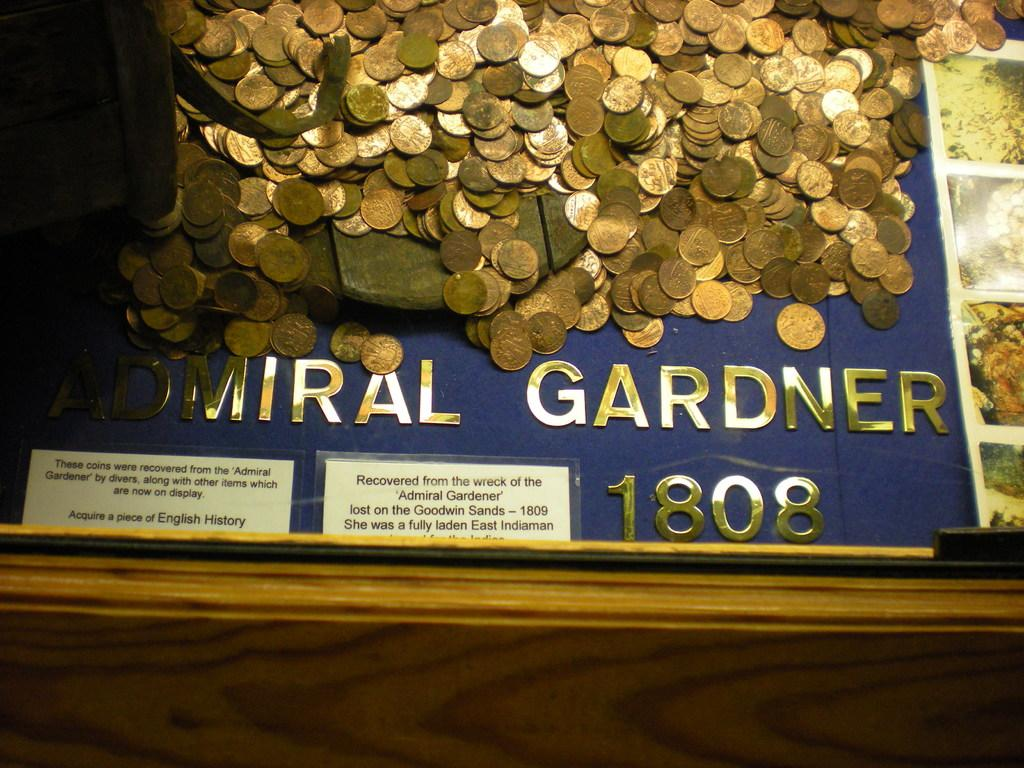<image>
Present a compact description of the photo's key features. A display is marked with the year 1808 and has a lot of pennies on it. 